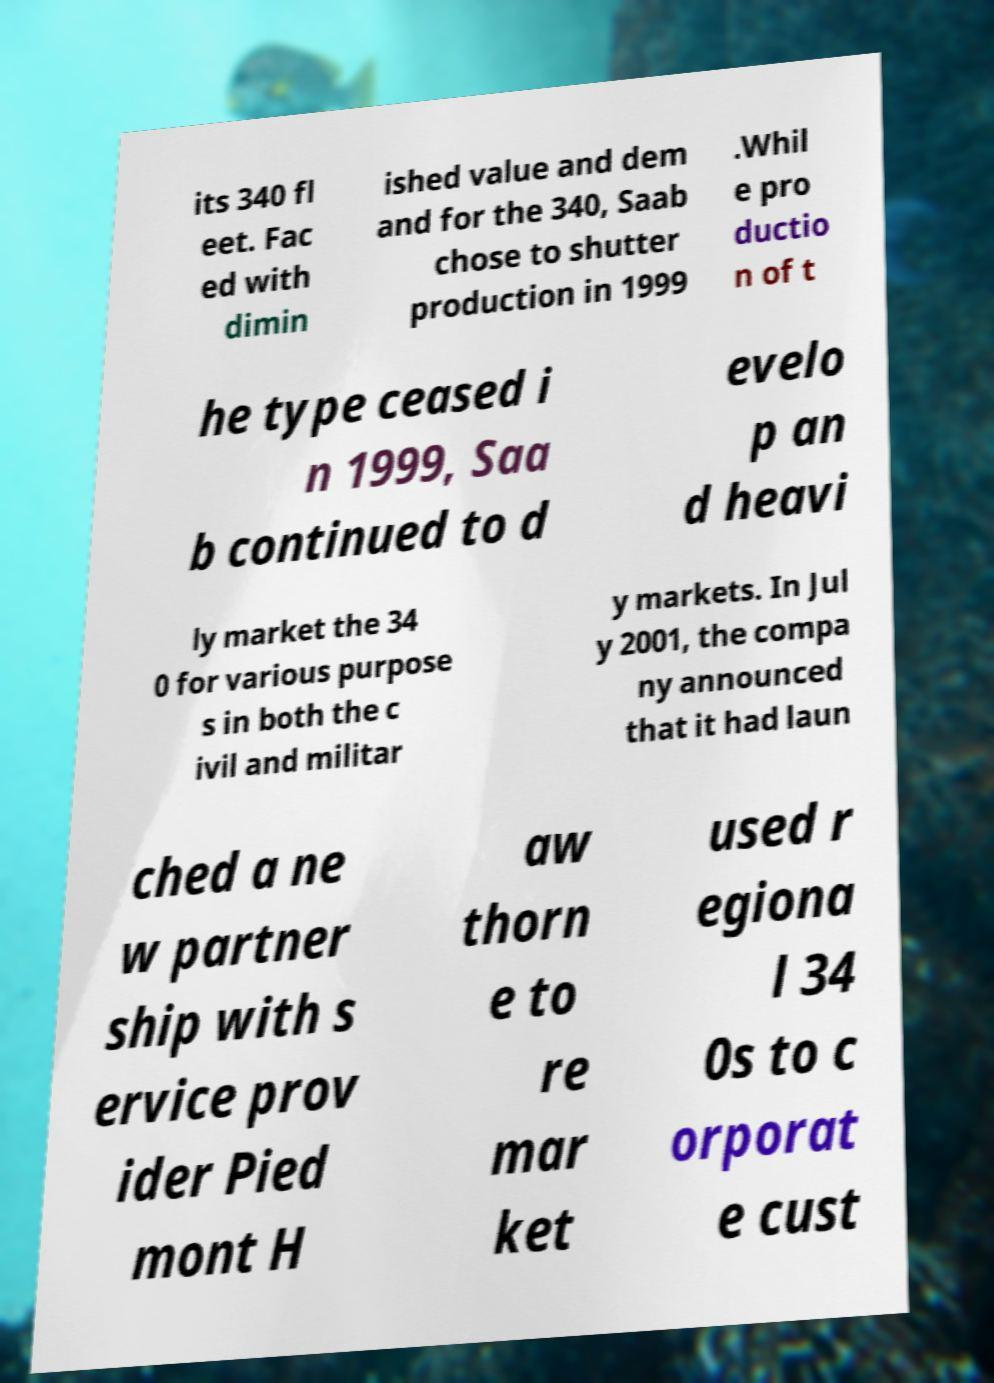Please identify and transcribe the text found in this image. its 340 fl eet. Fac ed with dimin ished value and dem and for the 340, Saab chose to shutter production in 1999 .Whil e pro ductio n of t he type ceased i n 1999, Saa b continued to d evelo p an d heavi ly market the 34 0 for various purpose s in both the c ivil and militar y markets. In Jul y 2001, the compa ny announced that it had laun ched a ne w partner ship with s ervice prov ider Pied mont H aw thorn e to re mar ket used r egiona l 34 0s to c orporat e cust 